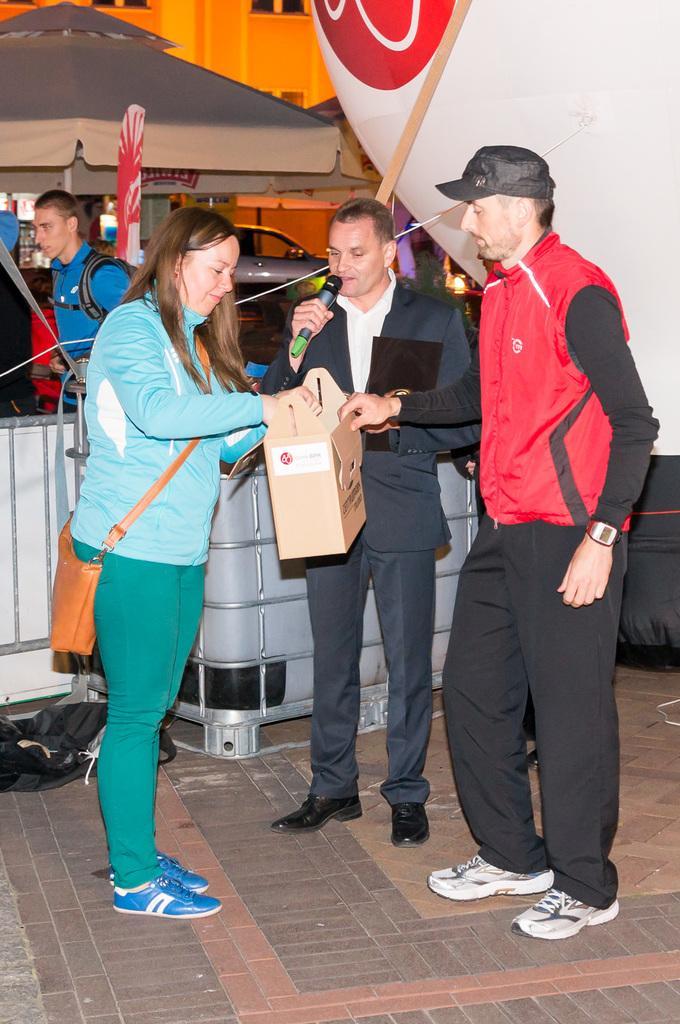In one or two sentences, can you explain what this image depicts? In this picture we can see few people, in the middle of the image we can see a man, he is holding a box and a microphone, beside him we can find few metal rods, in the background we can see an umbrella and a car. 